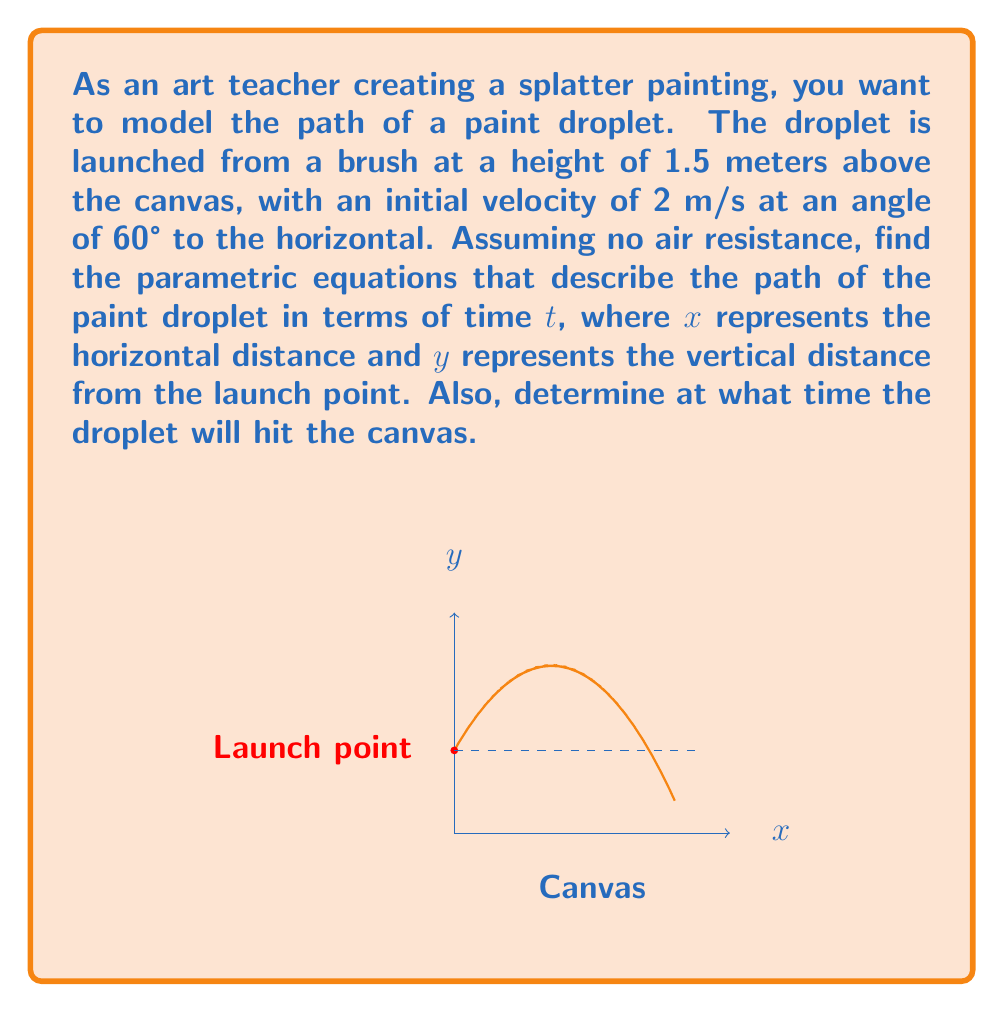Teach me how to tackle this problem. Let's approach this step-by-step:

1) The parametric equations for projectile motion are:

   $x(t) = v_0 \cos(\theta) t$
   $y(t) = y_0 + v_0 \sin(\theta) t - \frac{1}{2}gt^2$

   Where:
   $v_0$ is the initial velocity
   $\theta$ is the launch angle
   $y_0$ is the initial height
   $g$ is the acceleration due to gravity (9.8 m/s²)

2) We're given:
   $v_0 = 2$ m/s
   $\theta = 60°$ (or $\pi/3$ radians)
   $y_0 = 1.5$ m

3) Substituting these values:

   $x(t) = 2 \cos(60°) t = 2 \cdot \frac{1}{2} t = t$ m

   $y(t) = 1.5 + 2 \sin(60°) t - \frac{1}{2}(9.8)t^2$
         $= 1.5 + 2 \cdot \frac{\sqrt{3}}{2} t - 4.9t^2$
         $= 1.5 + \sqrt{3} t - 4.9t^2$ m

4) To find when the droplet hits the canvas, we need to solve $y(t) = 0$:

   $1.5 + \sqrt{3} t - 4.9t^2 = 0$

   This is a quadratic equation. We can solve it using the quadratic formula:

   $t = \frac{-b \pm \sqrt{b^2 - 4ac}}{2a}$

   Where $a = -4.9$, $b = \sqrt{3}$, and $c = 1.5$

5) Solving this:

   $t = \frac{-\sqrt{3} \pm \sqrt{3 - 4(-4.9)(1.5)}}{2(-4.9)}$
      $= \frac{-\sqrt{3} \pm \sqrt{32.4}}{-9.8}$
      $= \frac{-\sqrt{3} \pm 5.69}{-9.8}$

   The positive solution is approximately 0.62 seconds.
Answer: $x(t) = t$, $y(t) = 1.5 + \sqrt{3}t - 4.9t^2$, $t \approx 0.62$ s 